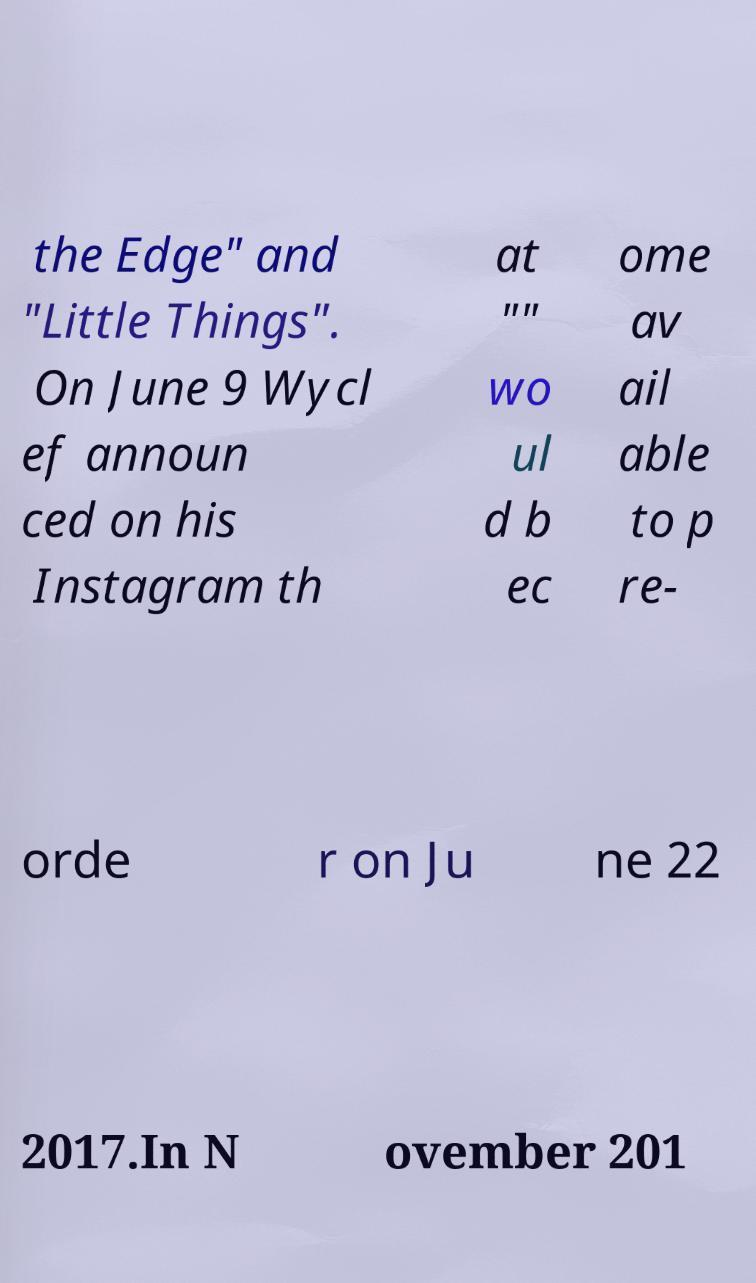Can you accurately transcribe the text from the provided image for me? the Edge" and "Little Things". On June 9 Wycl ef announ ced on his Instagram th at "" wo ul d b ec ome av ail able to p re- orde r on Ju ne 22 2017.In N ovember 201 